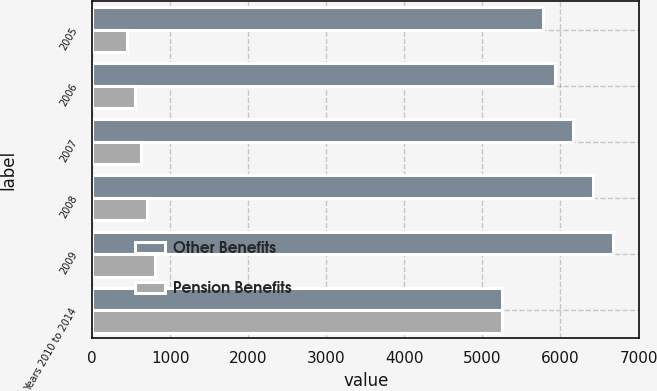<chart> <loc_0><loc_0><loc_500><loc_500><stacked_bar_chart><ecel><fcel>2005<fcel>2006<fcel>2007<fcel>2008<fcel>2009<fcel>Years 2010 to 2014<nl><fcel>Other Benefits<fcel>5779<fcel>5935<fcel>6156<fcel>6410<fcel>6678<fcel>5252<nl><fcel>Pension Benefits<fcel>441<fcel>552<fcel>627<fcel>707<fcel>807<fcel>5252<nl></chart> 